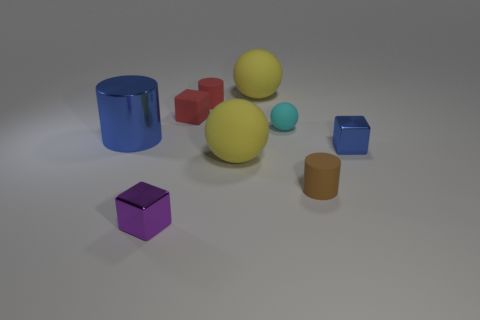Add 1 red objects. How many objects exist? 10 Subtract all cylinders. How many objects are left? 6 Subtract 0 red balls. How many objects are left? 9 Subtract all blue things. Subtract all small yellow cylinders. How many objects are left? 7 Add 8 large metal cylinders. How many large metal cylinders are left? 9 Add 5 small purple shiny cubes. How many small purple shiny cubes exist? 6 